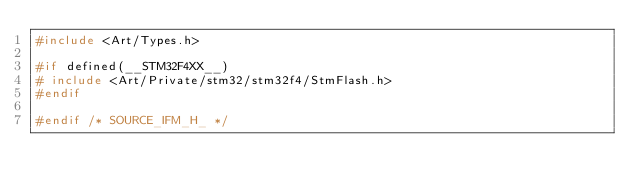Convert code to text. <code><loc_0><loc_0><loc_500><loc_500><_C_>#include <Art/Types.h>

#if defined(__STM32F4XX__)
#	include <Art/Private/stm32/stm32f4/StmFlash.h>
#endif

#endif /* SOURCE_IFM_H_ */
</code> 